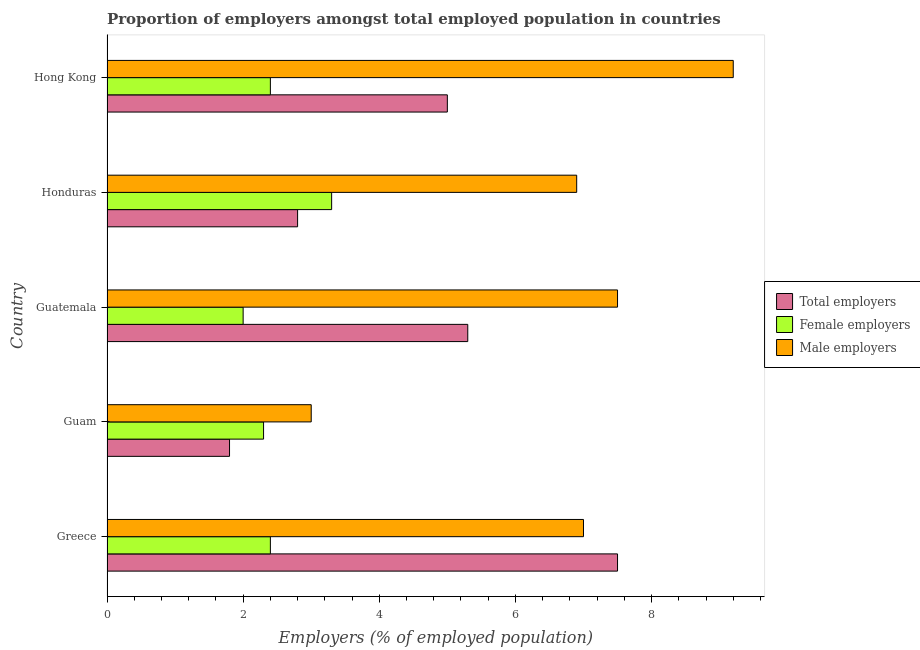How many different coloured bars are there?
Your answer should be very brief. 3. How many groups of bars are there?
Your answer should be very brief. 5. Are the number of bars per tick equal to the number of legend labels?
Ensure brevity in your answer.  Yes. Are the number of bars on each tick of the Y-axis equal?
Provide a succinct answer. Yes. How many bars are there on the 5th tick from the bottom?
Ensure brevity in your answer.  3. What is the percentage of total employers in Greece?
Provide a succinct answer. 7.5. Across all countries, what is the maximum percentage of male employers?
Provide a short and direct response. 9.2. In which country was the percentage of female employers maximum?
Provide a succinct answer. Honduras. In which country was the percentage of female employers minimum?
Offer a very short reply. Guatemala. What is the total percentage of male employers in the graph?
Your answer should be very brief. 33.6. What is the difference between the percentage of female employers in Honduras and the percentage of total employers in Greece?
Your response must be concise. -4.2. What is the average percentage of female employers per country?
Keep it short and to the point. 2.48. In how many countries, is the percentage of female employers greater than 2 %?
Ensure brevity in your answer.  4. What is the ratio of the percentage of female employers in Guam to that in Honduras?
Your response must be concise. 0.7. What is the difference between the highest and the lowest percentage of male employers?
Ensure brevity in your answer.  6.2. Is the sum of the percentage of total employers in Guatemala and Hong Kong greater than the maximum percentage of female employers across all countries?
Make the answer very short. Yes. What does the 1st bar from the top in Greece represents?
Offer a terse response. Male employers. What does the 2nd bar from the bottom in Hong Kong represents?
Your answer should be very brief. Female employers. How many bars are there?
Your response must be concise. 15. How many countries are there in the graph?
Give a very brief answer. 5. What is the difference between two consecutive major ticks on the X-axis?
Offer a terse response. 2. Are the values on the major ticks of X-axis written in scientific E-notation?
Offer a terse response. No. How many legend labels are there?
Keep it short and to the point. 3. How are the legend labels stacked?
Ensure brevity in your answer.  Vertical. What is the title of the graph?
Offer a very short reply. Proportion of employers amongst total employed population in countries. What is the label or title of the X-axis?
Provide a short and direct response. Employers (% of employed population). What is the Employers (% of employed population) in Female employers in Greece?
Keep it short and to the point. 2.4. What is the Employers (% of employed population) of Total employers in Guam?
Give a very brief answer. 1.8. What is the Employers (% of employed population) in Female employers in Guam?
Give a very brief answer. 2.3. What is the Employers (% of employed population) of Male employers in Guam?
Offer a terse response. 3. What is the Employers (% of employed population) of Total employers in Guatemala?
Make the answer very short. 5.3. What is the Employers (% of employed population) in Female employers in Guatemala?
Provide a succinct answer. 2. What is the Employers (% of employed population) in Total employers in Honduras?
Make the answer very short. 2.8. What is the Employers (% of employed population) of Female employers in Honduras?
Ensure brevity in your answer.  3.3. What is the Employers (% of employed population) of Male employers in Honduras?
Provide a short and direct response. 6.9. What is the Employers (% of employed population) of Total employers in Hong Kong?
Your answer should be compact. 5. What is the Employers (% of employed population) of Female employers in Hong Kong?
Your answer should be compact. 2.4. What is the Employers (% of employed population) in Male employers in Hong Kong?
Make the answer very short. 9.2. Across all countries, what is the maximum Employers (% of employed population) of Total employers?
Your answer should be compact. 7.5. Across all countries, what is the maximum Employers (% of employed population) of Female employers?
Offer a very short reply. 3.3. Across all countries, what is the maximum Employers (% of employed population) in Male employers?
Keep it short and to the point. 9.2. Across all countries, what is the minimum Employers (% of employed population) in Total employers?
Make the answer very short. 1.8. Across all countries, what is the minimum Employers (% of employed population) of Male employers?
Keep it short and to the point. 3. What is the total Employers (% of employed population) of Total employers in the graph?
Your answer should be very brief. 22.4. What is the total Employers (% of employed population) of Female employers in the graph?
Give a very brief answer. 12.4. What is the total Employers (% of employed population) in Male employers in the graph?
Provide a short and direct response. 33.6. What is the difference between the Employers (% of employed population) in Total employers in Greece and that in Guam?
Your answer should be very brief. 5.7. What is the difference between the Employers (% of employed population) in Male employers in Greece and that in Guam?
Provide a succinct answer. 4. What is the difference between the Employers (% of employed population) of Total employers in Greece and that in Guatemala?
Give a very brief answer. 2.2. What is the difference between the Employers (% of employed population) in Total employers in Greece and that in Honduras?
Your response must be concise. 4.7. What is the difference between the Employers (% of employed population) in Female employers in Greece and that in Honduras?
Your response must be concise. -0.9. What is the difference between the Employers (% of employed population) of Male employers in Greece and that in Honduras?
Ensure brevity in your answer.  0.1. What is the difference between the Employers (% of employed population) in Male employers in Greece and that in Hong Kong?
Provide a succinct answer. -2.2. What is the difference between the Employers (% of employed population) in Female employers in Guam and that in Guatemala?
Provide a short and direct response. 0.3. What is the difference between the Employers (% of employed population) of Female employers in Guam and that in Honduras?
Provide a succinct answer. -1. What is the difference between the Employers (% of employed population) of Male employers in Guam and that in Honduras?
Offer a terse response. -3.9. What is the difference between the Employers (% of employed population) in Total employers in Guam and that in Hong Kong?
Give a very brief answer. -3.2. What is the difference between the Employers (% of employed population) of Female employers in Guam and that in Hong Kong?
Offer a terse response. -0.1. What is the difference between the Employers (% of employed population) of Male employers in Guam and that in Hong Kong?
Provide a short and direct response. -6.2. What is the difference between the Employers (% of employed population) in Total employers in Guatemala and that in Honduras?
Give a very brief answer. 2.5. What is the difference between the Employers (% of employed population) in Female employers in Guatemala and that in Honduras?
Your answer should be compact. -1.3. What is the difference between the Employers (% of employed population) in Male employers in Guatemala and that in Honduras?
Provide a short and direct response. 0.6. What is the difference between the Employers (% of employed population) of Male employers in Guatemala and that in Hong Kong?
Provide a short and direct response. -1.7. What is the difference between the Employers (% of employed population) in Total employers in Honduras and that in Hong Kong?
Give a very brief answer. -2.2. What is the difference between the Employers (% of employed population) of Female employers in Greece and the Employers (% of employed population) of Male employers in Guam?
Your answer should be very brief. -0.6. What is the difference between the Employers (% of employed population) of Total employers in Greece and the Employers (% of employed population) of Female employers in Honduras?
Ensure brevity in your answer.  4.2. What is the difference between the Employers (% of employed population) of Total employers in Greece and the Employers (% of employed population) of Male employers in Honduras?
Give a very brief answer. 0.6. What is the difference between the Employers (% of employed population) of Total employers in Greece and the Employers (% of employed population) of Female employers in Hong Kong?
Your answer should be very brief. 5.1. What is the difference between the Employers (% of employed population) in Female employers in Greece and the Employers (% of employed population) in Male employers in Hong Kong?
Provide a short and direct response. -6.8. What is the difference between the Employers (% of employed population) of Total employers in Guam and the Employers (% of employed population) of Female employers in Guatemala?
Your response must be concise. -0.2. What is the difference between the Employers (% of employed population) in Total employers in Guam and the Employers (% of employed population) in Male employers in Guatemala?
Offer a very short reply. -5.7. What is the difference between the Employers (% of employed population) of Female employers in Guam and the Employers (% of employed population) of Male employers in Hong Kong?
Make the answer very short. -6.9. What is the difference between the Employers (% of employed population) in Total employers in Guatemala and the Employers (% of employed population) in Female employers in Hong Kong?
Provide a succinct answer. 2.9. What is the difference between the Employers (% of employed population) in Total employers in Guatemala and the Employers (% of employed population) in Male employers in Hong Kong?
Your answer should be compact. -3.9. What is the difference between the Employers (% of employed population) of Total employers in Honduras and the Employers (% of employed population) of Female employers in Hong Kong?
Keep it short and to the point. 0.4. What is the difference between the Employers (% of employed population) in Total employers in Honduras and the Employers (% of employed population) in Male employers in Hong Kong?
Make the answer very short. -6.4. What is the average Employers (% of employed population) of Total employers per country?
Provide a short and direct response. 4.48. What is the average Employers (% of employed population) in Female employers per country?
Your answer should be very brief. 2.48. What is the average Employers (% of employed population) of Male employers per country?
Keep it short and to the point. 6.72. What is the difference between the Employers (% of employed population) of Female employers and Employers (% of employed population) of Male employers in Greece?
Provide a short and direct response. -4.6. What is the difference between the Employers (% of employed population) in Total employers and Employers (% of employed population) in Female employers in Guam?
Provide a short and direct response. -0.5. What is the difference between the Employers (% of employed population) in Female employers and Employers (% of employed population) in Male employers in Guam?
Make the answer very short. -0.7. What is the difference between the Employers (% of employed population) of Total employers and Employers (% of employed population) of Female employers in Guatemala?
Offer a terse response. 3.3. What is the difference between the Employers (% of employed population) in Total employers and Employers (% of employed population) in Female employers in Honduras?
Your answer should be compact. -0.5. What is the difference between the Employers (% of employed population) in Total employers and Employers (% of employed population) in Male employers in Honduras?
Give a very brief answer. -4.1. What is the difference between the Employers (% of employed population) in Total employers and Employers (% of employed population) in Male employers in Hong Kong?
Ensure brevity in your answer.  -4.2. What is the difference between the Employers (% of employed population) of Female employers and Employers (% of employed population) of Male employers in Hong Kong?
Give a very brief answer. -6.8. What is the ratio of the Employers (% of employed population) in Total employers in Greece to that in Guam?
Your response must be concise. 4.17. What is the ratio of the Employers (% of employed population) in Female employers in Greece to that in Guam?
Provide a short and direct response. 1.04. What is the ratio of the Employers (% of employed population) in Male employers in Greece to that in Guam?
Keep it short and to the point. 2.33. What is the ratio of the Employers (% of employed population) of Total employers in Greece to that in Guatemala?
Your response must be concise. 1.42. What is the ratio of the Employers (% of employed population) in Total employers in Greece to that in Honduras?
Offer a very short reply. 2.68. What is the ratio of the Employers (% of employed population) of Female employers in Greece to that in Honduras?
Keep it short and to the point. 0.73. What is the ratio of the Employers (% of employed population) of Male employers in Greece to that in Honduras?
Ensure brevity in your answer.  1.01. What is the ratio of the Employers (% of employed population) in Male employers in Greece to that in Hong Kong?
Offer a very short reply. 0.76. What is the ratio of the Employers (% of employed population) in Total employers in Guam to that in Guatemala?
Offer a very short reply. 0.34. What is the ratio of the Employers (% of employed population) of Female employers in Guam to that in Guatemala?
Your answer should be very brief. 1.15. What is the ratio of the Employers (% of employed population) of Male employers in Guam to that in Guatemala?
Give a very brief answer. 0.4. What is the ratio of the Employers (% of employed population) in Total employers in Guam to that in Honduras?
Provide a succinct answer. 0.64. What is the ratio of the Employers (% of employed population) in Female employers in Guam to that in Honduras?
Keep it short and to the point. 0.7. What is the ratio of the Employers (% of employed population) of Male employers in Guam to that in Honduras?
Make the answer very short. 0.43. What is the ratio of the Employers (% of employed population) in Total employers in Guam to that in Hong Kong?
Offer a terse response. 0.36. What is the ratio of the Employers (% of employed population) of Female employers in Guam to that in Hong Kong?
Your answer should be compact. 0.96. What is the ratio of the Employers (% of employed population) in Male employers in Guam to that in Hong Kong?
Make the answer very short. 0.33. What is the ratio of the Employers (% of employed population) of Total employers in Guatemala to that in Honduras?
Make the answer very short. 1.89. What is the ratio of the Employers (% of employed population) of Female employers in Guatemala to that in Honduras?
Give a very brief answer. 0.61. What is the ratio of the Employers (% of employed population) in Male employers in Guatemala to that in Honduras?
Give a very brief answer. 1.09. What is the ratio of the Employers (% of employed population) in Total employers in Guatemala to that in Hong Kong?
Your response must be concise. 1.06. What is the ratio of the Employers (% of employed population) in Male employers in Guatemala to that in Hong Kong?
Keep it short and to the point. 0.82. What is the ratio of the Employers (% of employed population) of Total employers in Honduras to that in Hong Kong?
Your answer should be compact. 0.56. What is the ratio of the Employers (% of employed population) of Female employers in Honduras to that in Hong Kong?
Your answer should be very brief. 1.38. What is the ratio of the Employers (% of employed population) in Male employers in Honduras to that in Hong Kong?
Your answer should be very brief. 0.75. What is the difference between the highest and the second highest Employers (% of employed population) of Total employers?
Ensure brevity in your answer.  2.2. What is the difference between the highest and the second highest Employers (% of employed population) of Male employers?
Provide a succinct answer. 1.7. What is the difference between the highest and the lowest Employers (% of employed population) in Male employers?
Keep it short and to the point. 6.2. 